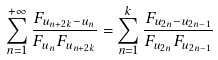<formula> <loc_0><loc_0><loc_500><loc_500>\sum _ { n = 1 } ^ { + \infty } \frac { F _ { u _ { n + 2 k } - u _ { n } } } { F _ { u _ { n } } F _ { u _ { n + 2 k } } } = \sum _ { n = 1 } ^ { k } \frac { F _ { u _ { 2 n } - u _ { 2 n - 1 } } } { F _ { u _ { 2 n } } F _ { u _ { 2 n - 1 } } }</formula> 